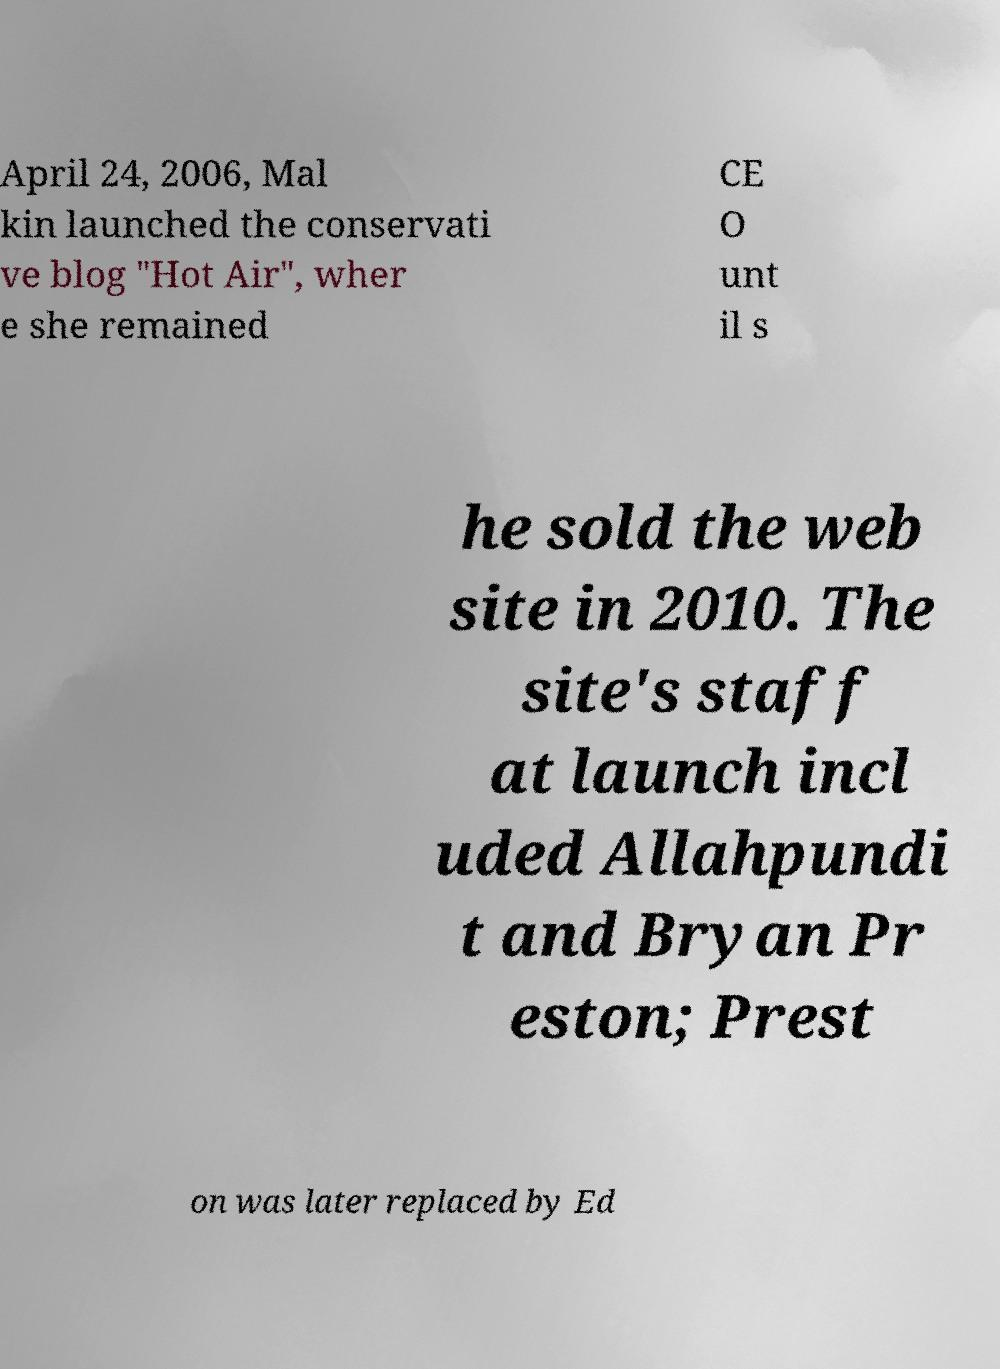I need the written content from this picture converted into text. Can you do that? April 24, 2006, Mal kin launched the conservati ve blog "Hot Air", wher e she remained CE O unt il s he sold the web site in 2010. The site's staff at launch incl uded Allahpundi t and Bryan Pr eston; Prest on was later replaced by Ed 